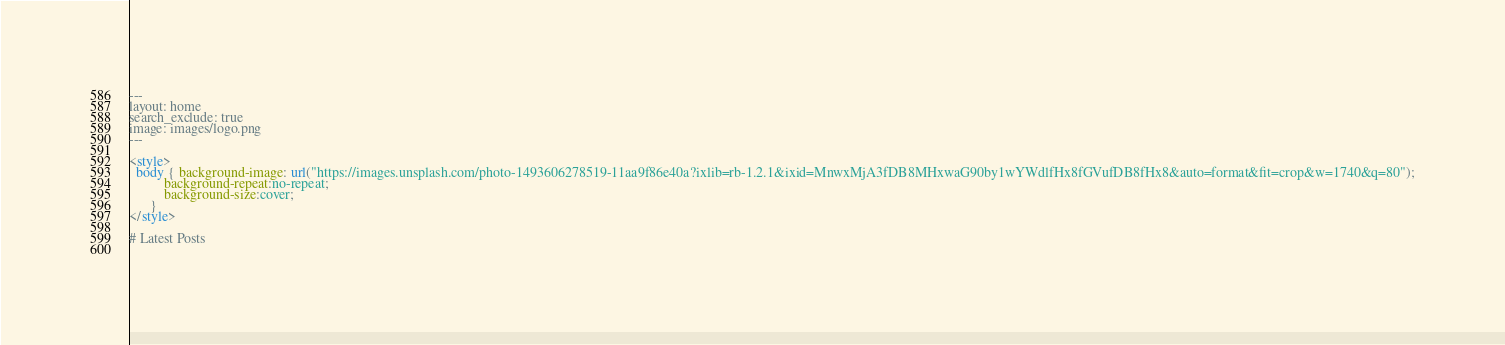<code> <loc_0><loc_0><loc_500><loc_500><_HTML_>---
layout: home
search_exclude: true
image: images/logo.png
---

<style>
  body { background-image: url("https://images.unsplash.com/photo-1493606278519-11aa9f86e40a?ixlib=rb-1.2.1&ixid=MnwxMjA3fDB8MHxwaG90by1wYWdlfHx8fGVufDB8fHx8&auto=format&fit=crop&w=1740&q=80");
          background-repeat:no-repeat;
          background-size:cover;
      } 
</style>

# Latest Posts
              
</code> 